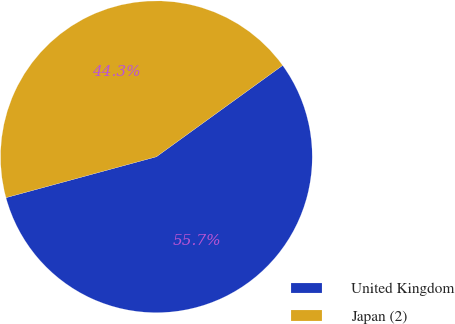<chart> <loc_0><loc_0><loc_500><loc_500><pie_chart><fcel>United Kingdom<fcel>Japan (2)<nl><fcel>55.74%<fcel>44.26%<nl></chart> 